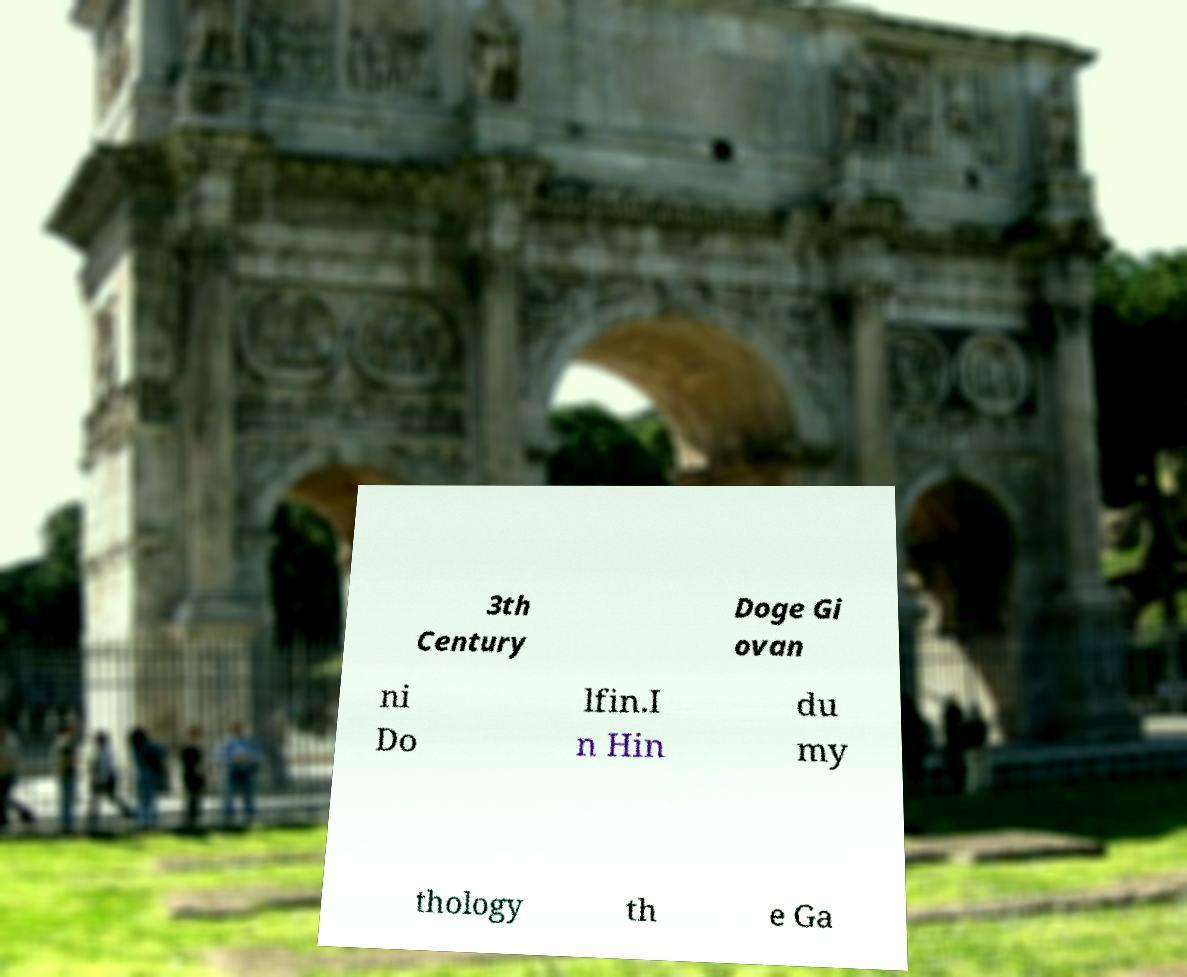There's text embedded in this image that I need extracted. Can you transcribe it verbatim? 3th Century Doge Gi ovan ni Do lfin.I n Hin du my thology th e Ga 